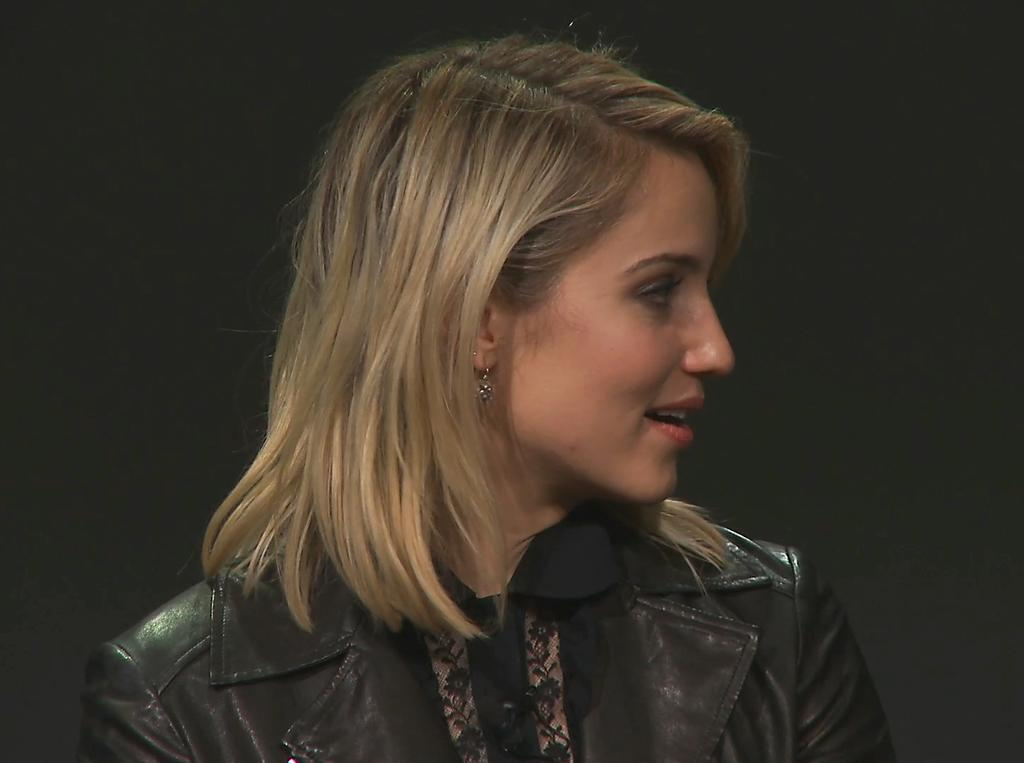Who or what is the main subject in the image? There is a person in the image. What is the person wearing? The person is wearing a black jacket. What can be observed about the background of the image? The background of the image is dark. What type of breakfast is the person eating in the image? There is no indication of breakfast or any food in the image. 